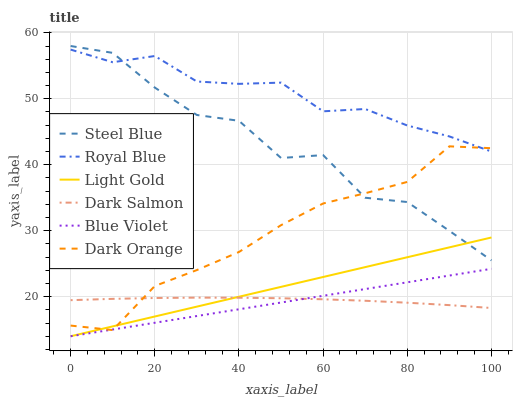Does Blue Violet have the minimum area under the curve?
Answer yes or no. Yes. Does Royal Blue have the maximum area under the curve?
Answer yes or no. Yes. Does Steel Blue have the minimum area under the curve?
Answer yes or no. No. Does Steel Blue have the maximum area under the curve?
Answer yes or no. No. Is Light Gold the smoothest?
Answer yes or no. Yes. Is Steel Blue the roughest?
Answer yes or no. Yes. Is Dark Salmon the smoothest?
Answer yes or no. No. Is Dark Salmon the roughest?
Answer yes or no. No. Does Light Gold have the lowest value?
Answer yes or no. Yes. Does Steel Blue have the lowest value?
Answer yes or no. No. Does Steel Blue have the highest value?
Answer yes or no. Yes. Does Dark Salmon have the highest value?
Answer yes or no. No. Is Dark Salmon less than Royal Blue?
Answer yes or no. Yes. Is Royal Blue greater than Light Gold?
Answer yes or no. Yes. Does Blue Violet intersect Dark Salmon?
Answer yes or no. Yes. Is Blue Violet less than Dark Salmon?
Answer yes or no. No. Is Blue Violet greater than Dark Salmon?
Answer yes or no. No. Does Dark Salmon intersect Royal Blue?
Answer yes or no. No. 